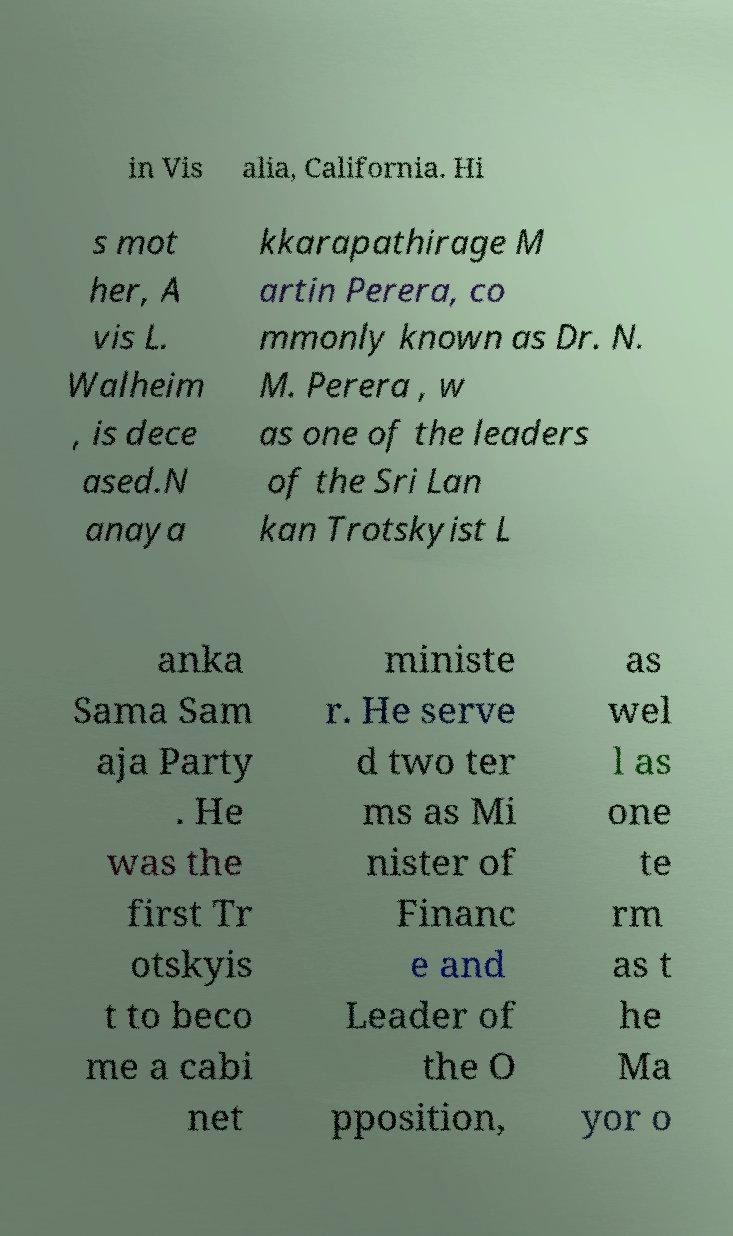Can you read and provide the text displayed in the image?This photo seems to have some interesting text. Can you extract and type it out for me? in Vis alia, California. Hi s mot her, A vis L. Walheim , is dece ased.N anaya kkarapathirage M artin Perera, co mmonly known as Dr. N. M. Perera , w as one of the leaders of the Sri Lan kan Trotskyist L anka Sama Sam aja Party . He was the first Tr otskyis t to beco me a cabi net ministe r. He serve d two ter ms as Mi nister of Financ e and Leader of the O pposition, as wel l as one te rm as t he Ma yor o 